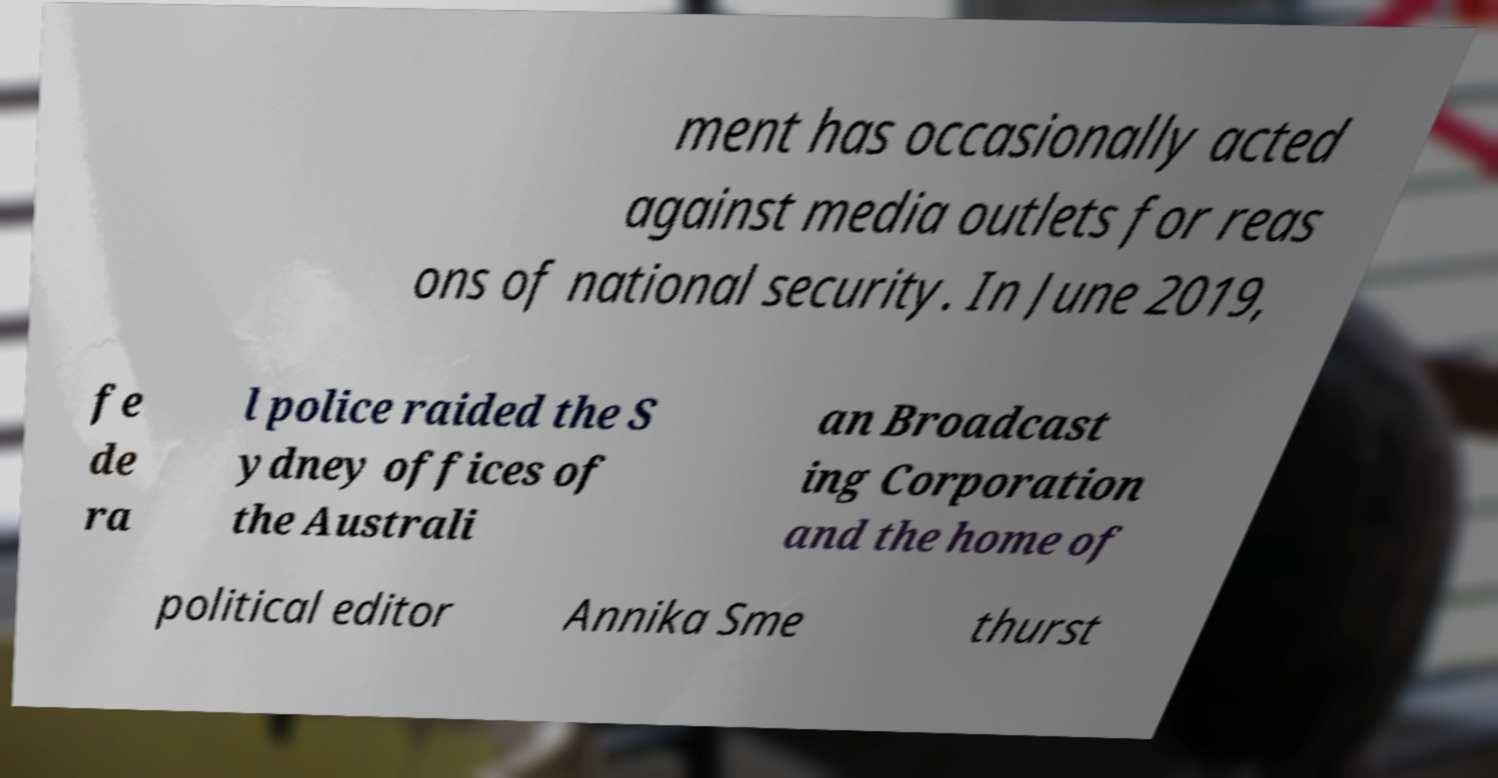What messages or text are displayed in this image? I need them in a readable, typed format. ment has occasionally acted against media outlets for reas ons of national security. In June 2019, fe de ra l police raided the S ydney offices of the Australi an Broadcast ing Corporation and the home of political editor Annika Sme thurst 